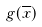<formula> <loc_0><loc_0><loc_500><loc_500>g ( \overline { x } )</formula> 